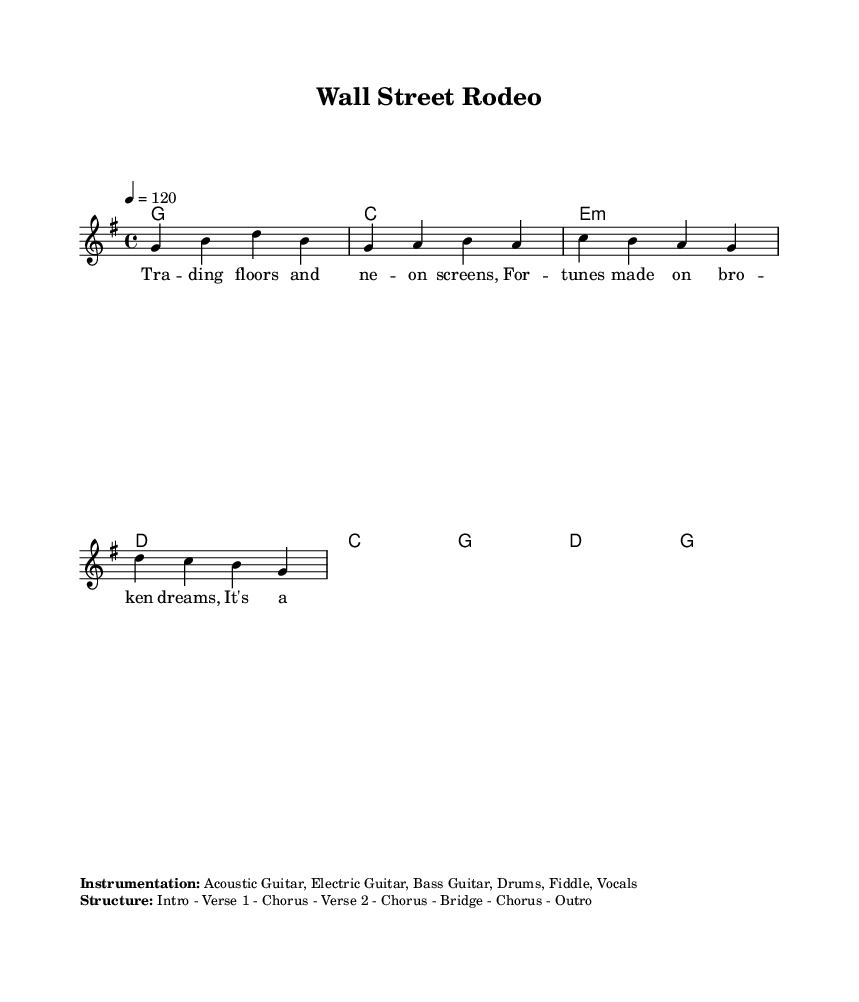What is the key signature of this music? The key signature is G major, which has one sharp (F#). This can be identified by looking at the key signature indicator at the beginning of the staff.
Answer: G major What is the time signature of this piece? The time signature is 4/4. This is indicated at the beginning of the score, showing that there are four beats per measure and the quarter note gets one beat.
Answer: 4/4 What is the tempo marking for this music? The tempo marking is 120 beats per minute. This is shown as “4 = 120” in the tempo indication, meaning to play at this speed.
Answer: 120 How many verses are in the structure of the music? The structure includes two verses as specified in the section labeled "Structure." Each verse is termed as "Verse 1" and "Verse 2."
Answer: Two What is the style of instrumentation featured in the piece? The instrumentation listed includes Acoustic Guitar, Electric Guitar, Bass Guitar, Drums, Fiddle, and Vocals. This diversity reflects typical instruments used in country music.
Answer: Acoustic Guitar, Electric Guitar, Bass Guitar, Drums, Fiddle, Vocals What message is conveyed in the thematic content of the lyrics? The lyrics critique corporate greed and financial inequality, which is evident in the phrases like "Trading floors and neon screens" and references to broken dreams, pointing out the struggles of the average person against wealth.
Answer: Critique of corporate greed and financial inequality 